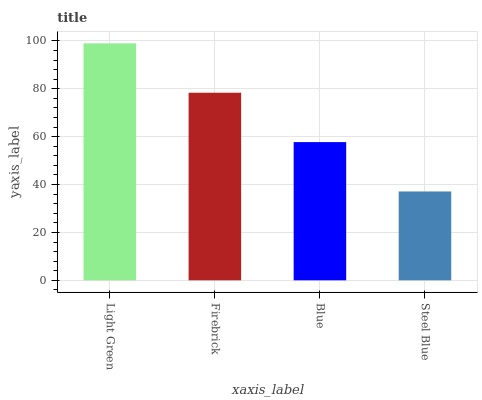Is Steel Blue the minimum?
Answer yes or no. Yes. Is Light Green the maximum?
Answer yes or no. Yes. Is Firebrick the minimum?
Answer yes or no. No. Is Firebrick the maximum?
Answer yes or no. No. Is Light Green greater than Firebrick?
Answer yes or no. Yes. Is Firebrick less than Light Green?
Answer yes or no. Yes. Is Firebrick greater than Light Green?
Answer yes or no. No. Is Light Green less than Firebrick?
Answer yes or no. No. Is Firebrick the high median?
Answer yes or no. Yes. Is Blue the low median?
Answer yes or no. Yes. Is Blue the high median?
Answer yes or no. No. Is Steel Blue the low median?
Answer yes or no. No. 